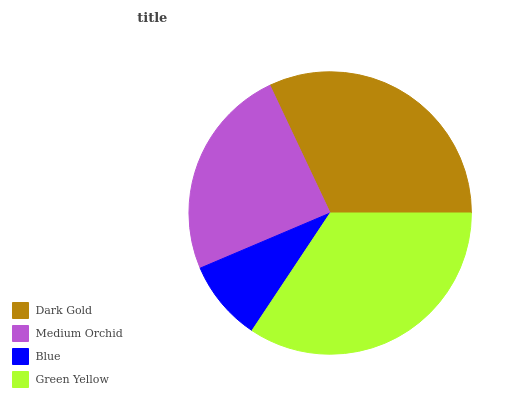Is Blue the minimum?
Answer yes or no. Yes. Is Green Yellow the maximum?
Answer yes or no. Yes. Is Medium Orchid the minimum?
Answer yes or no. No. Is Medium Orchid the maximum?
Answer yes or no. No. Is Dark Gold greater than Medium Orchid?
Answer yes or no. Yes. Is Medium Orchid less than Dark Gold?
Answer yes or no. Yes. Is Medium Orchid greater than Dark Gold?
Answer yes or no. No. Is Dark Gold less than Medium Orchid?
Answer yes or no. No. Is Dark Gold the high median?
Answer yes or no. Yes. Is Medium Orchid the low median?
Answer yes or no. Yes. Is Green Yellow the high median?
Answer yes or no. No. Is Blue the low median?
Answer yes or no. No. 